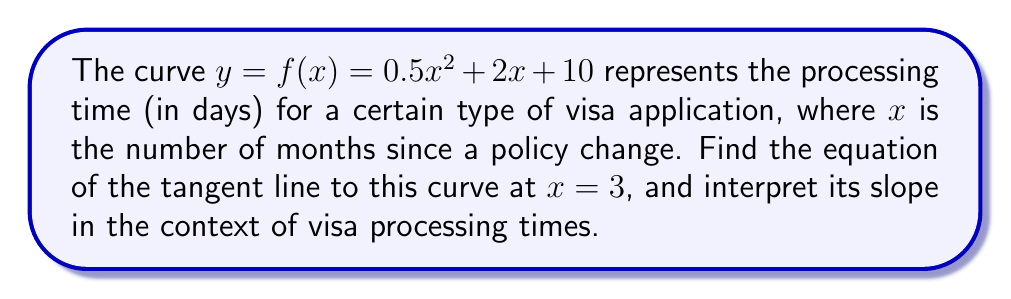Help me with this question. To find the tangent line, we need to follow these steps:

1) First, we need to find $f'(x)$, the derivative of $f(x)$:
   $$f'(x) = (0.5x^2 + 2x + 10)' = x + 2$$

2) Now, we evaluate $f'(3)$ to get the slope of the tangent line:
   $$f'(3) = 3 + 2 = 5$$

3) We also need to find $f(3)$, the y-coordinate of the point of tangency:
   $$f(3) = 0.5(3)^2 + 2(3) + 10 = 0.5(9) + 6 + 10 = 4.5 + 16 = 20.5$$

4) Now we have a point $(3, 20.5)$ and a slope of 5. We can use the point-slope form of a line:
   $$y - y_1 = m(x - x_1)$$
   $$y - 20.5 = 5(x - 3)$$

5) Simplify to get the equation of the tangent line:
   $$y = 5x - 15 + 20.5$$
   $$y = 5x + 5.5$$

Interpretation: The slope of 5 means that at 3 months after the policy change, the processing time is increasing at a rate of 5 days per month.
Answer: $y = 5x + 5.5$; slope of 5 days/month 